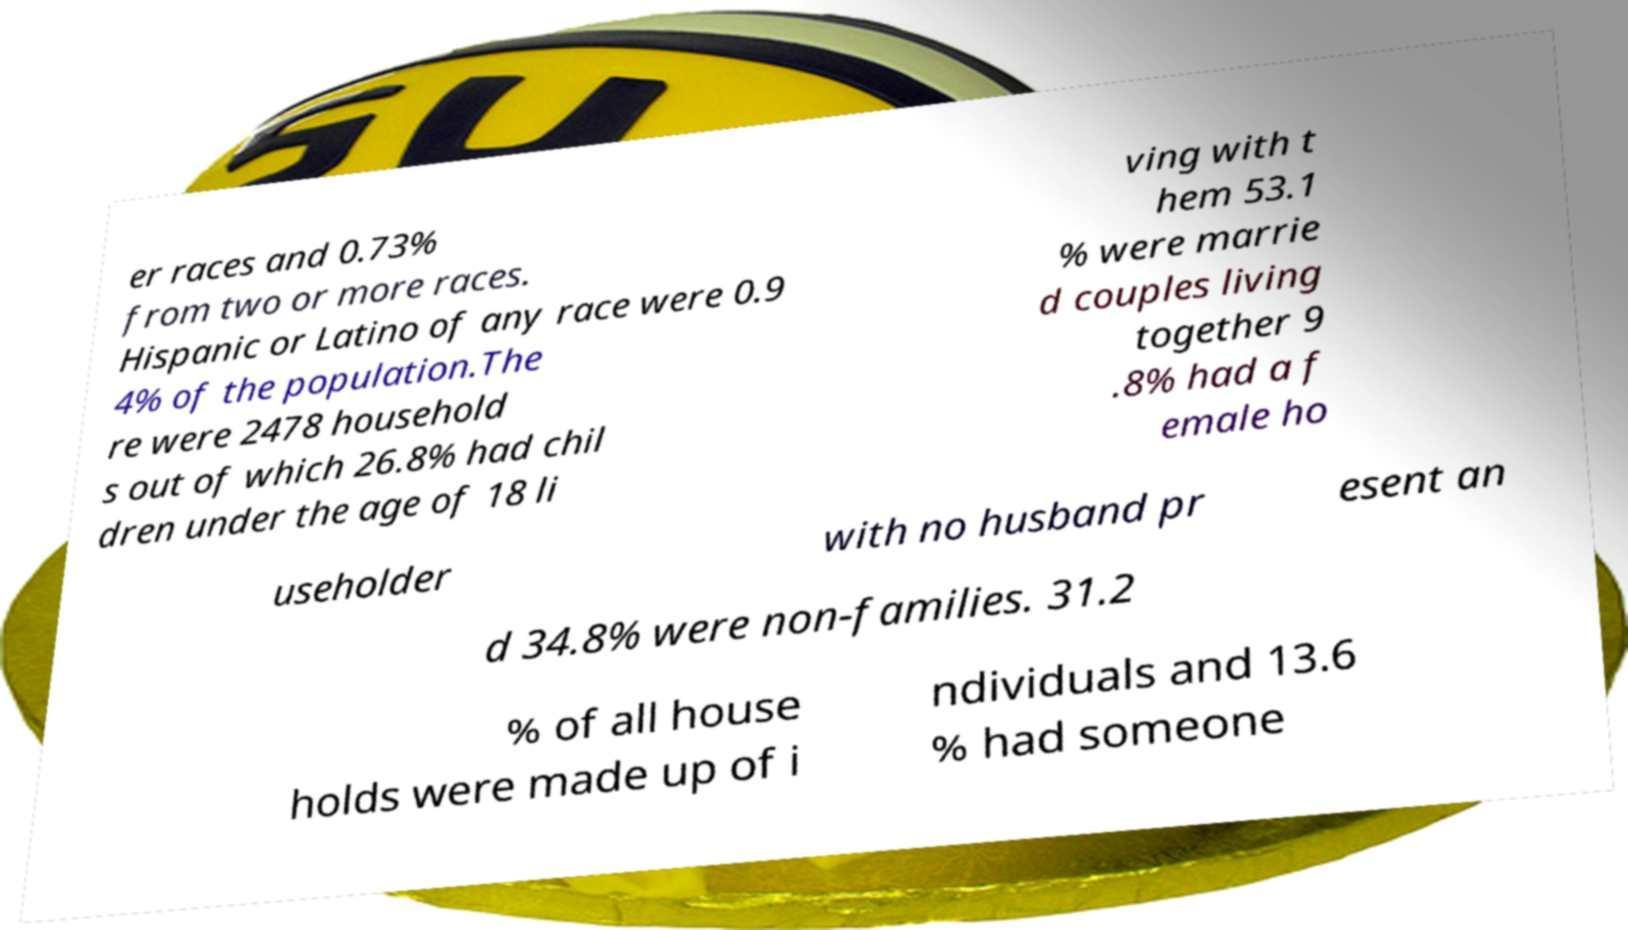Could you assist in decoding the text presented in this image and type it out clearly? er races and 0.73% from two or more races. Hispanic or Latino of any race were 0.9 4% of the population.The re were 2478 household s out of which 26.8% had chil dren under the age of 18 li ving with t hem 53.1 % were marrie d couples living together 9 .8% had a f emale ho useholder with no husband pr esent an d 34.8% were non-families. 31.2 % of all house holds were made up of i ndividuals and 13.6 % had someone 